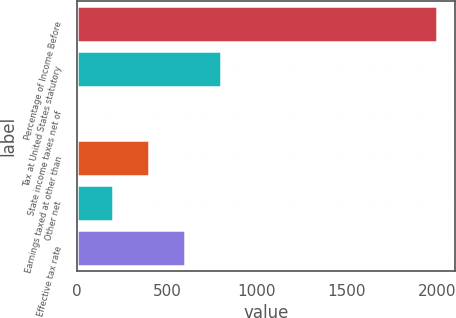Convert chart. <chart><loc_0><loc_0><loc_500><loc_500><bar_chart><fcel>Percentage of Income Before<fcel>Tax at United States statutory<fcel>State income taxes net of<fcel>Earnings taxed at other than<fcel>Other net<fcel>Effective tax rate<nl><fcel>2002<fcel>801.16<fcel>0.6<fcel>400.88<fcel>200.74<fcel>601.02<nl></chart> 